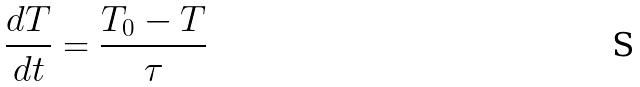Convert formula to latex. <formula><loc_0><loc_0><loc_500><loc_500>\frac { d T } { d t } = \frac { T _ { 0 } - T } { \tau }</formula> 